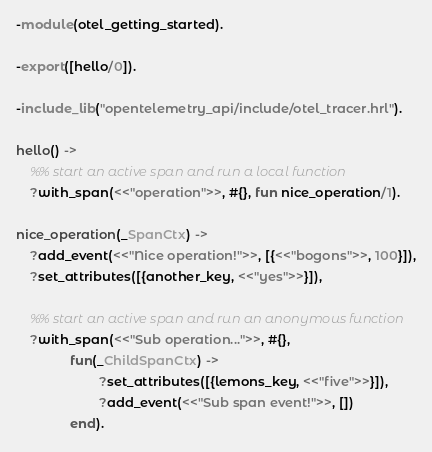Convert code to text. <code><loc_0><loc_0><loc_500><loc_500><_Erlang_>-module(otel_getting_started).

-export([hello/0]).

-include_lib("opentelemetry_api/include/otel_tracer.hrl").

hello() ->
    %% start an active span and run a local function
    ?with_span(<<"operation">>, #{}, fun nice_operation/1).

nice_operation(_SpanCtx) ->
    ?add_event(<<"Nice operation!">>, [{<<"bogons">>, 100}]),
    ?set_attributes([{another_key, <<"yes">>}]),

    %% start an active span and run an anonymous function
    ?with_span(<<"Sub operation...">>, #{},
               fun(_ChildSpanCtx) ->
                       ?set_attributes([{lemons_key, <<"five">>}]),
                       ?add_event(<<"Sub span event!">>, [])
               end).
</code> 